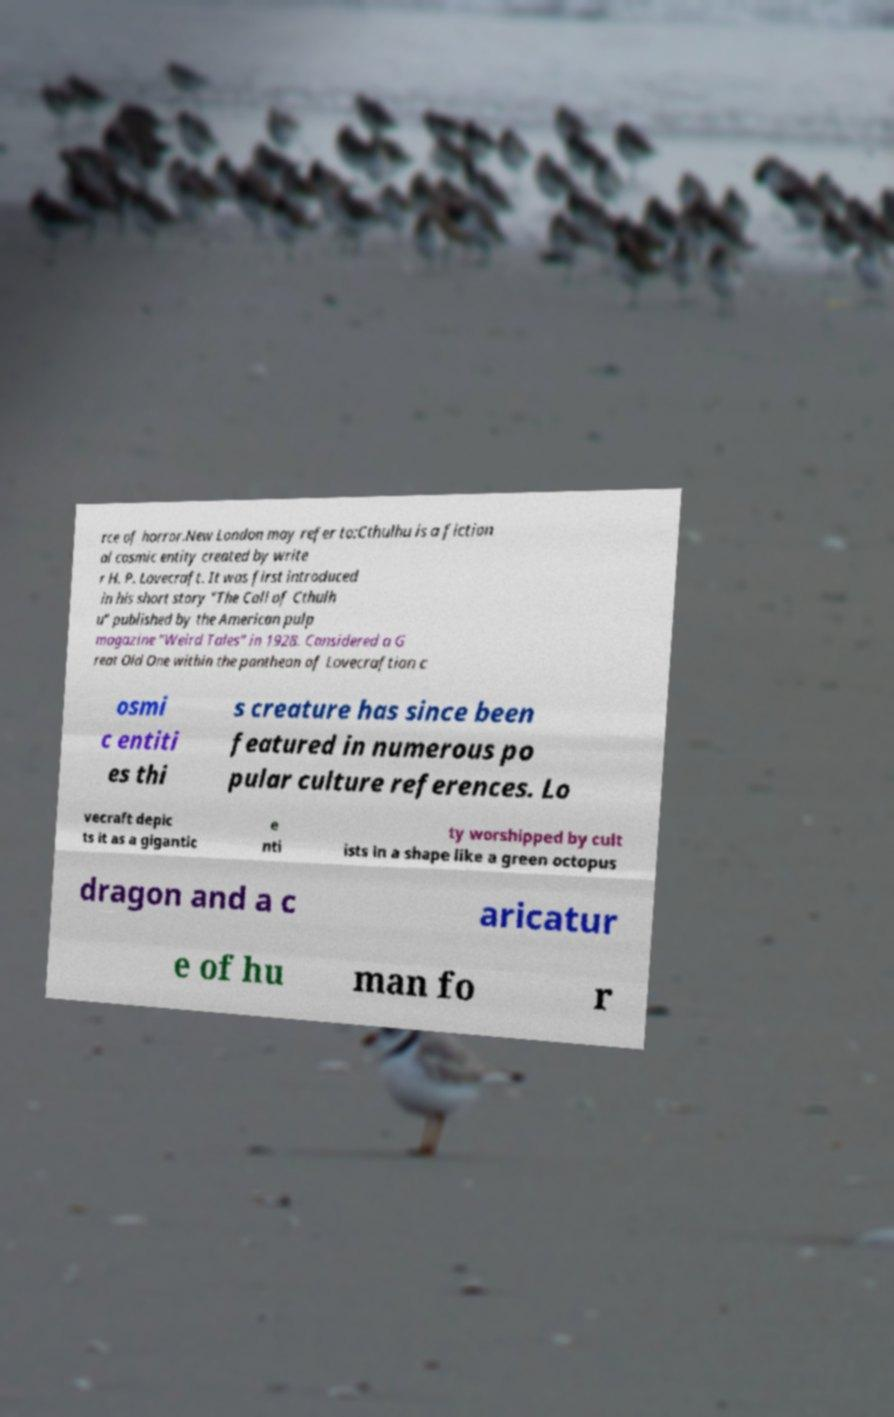Could you extract and type out the text from this image? rce of horror.New London may refer to:Cthulhu is a fiction al cosmic entity created by write r H. P. Lovecraft. It was first introduced in his short story "The Call of Cthulh u" published by the American pulp magazine "Weird Tales" in 1928. Considered a G reat Old One within the pantheon of Lovecraftian c osmi c entiti es thi s creature has since been featured in numerous po pular culture references. Lo vecraft depic ts it as a gigantic e nti ty worshipped by cult ists in a shape like a green octopus dragon and a c aricatur e of hu man fo r 